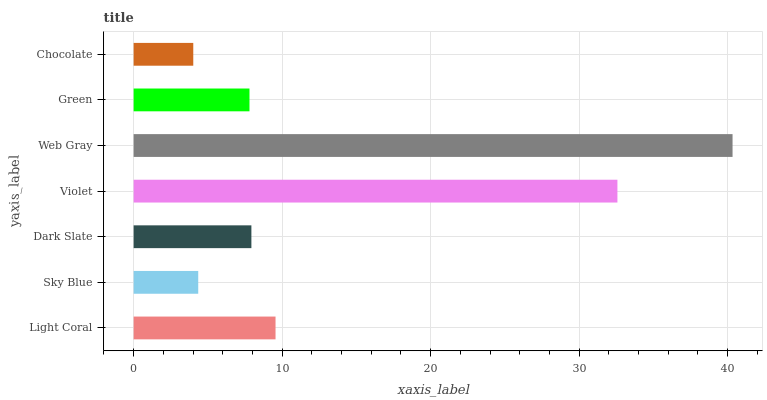Is Chocolate the minimum?
Answer yes or no. Yes. Is Web Gray the maximum?
Answer yes or no. Yes. Is Sky Blue the minimum?
Answer yes or no. No. Is Sky Blue the maximum?
Answer yes or no. No. Is Light Coral greater than Sky Blue?
Answer yes or no. Yes. Is Sky Blue less than Light Coral?
Answer yes or no. Yes. Is Sky Blue greater than Light Coral?
Answer yes or no. No. Is Light Coral less than Sky Blue?
Answer yes or no. No. Is Dark Slate the high median?
Answer yes or no. Yes. Is Dark Slate the low median?
Answer yes or no. Yes. Is Green the high median?
Answer yes or no. No. Is Violet the low median?
Answer yes or no. No. 